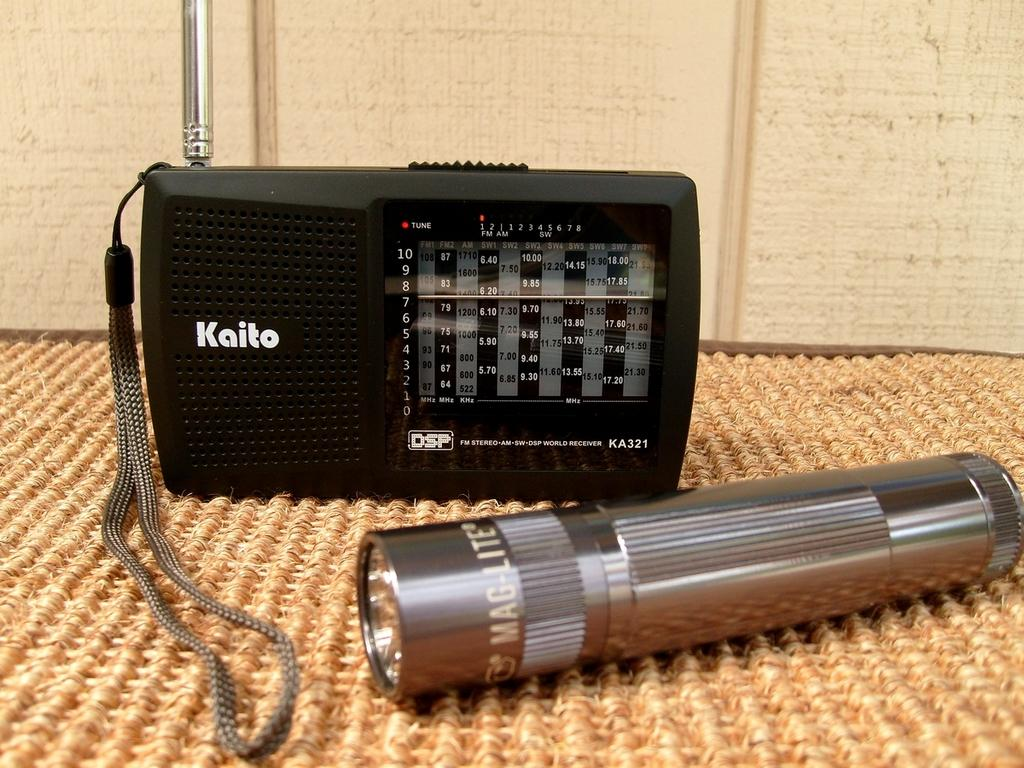What electronic device can be seen in the image? There is a radio in the image. What other object is present in the image? There is a torch in the image. Where are the radio and torch located? Both the radio and torch are on a mat. What can be seen in the background of the image? There is a board visible in the background of the image. How many arms are visible holding the radio in the image? There are no arms visible holding the radio in the image. Can you see a kitten playing with the torch in the image? There is no kitten present in the image. 